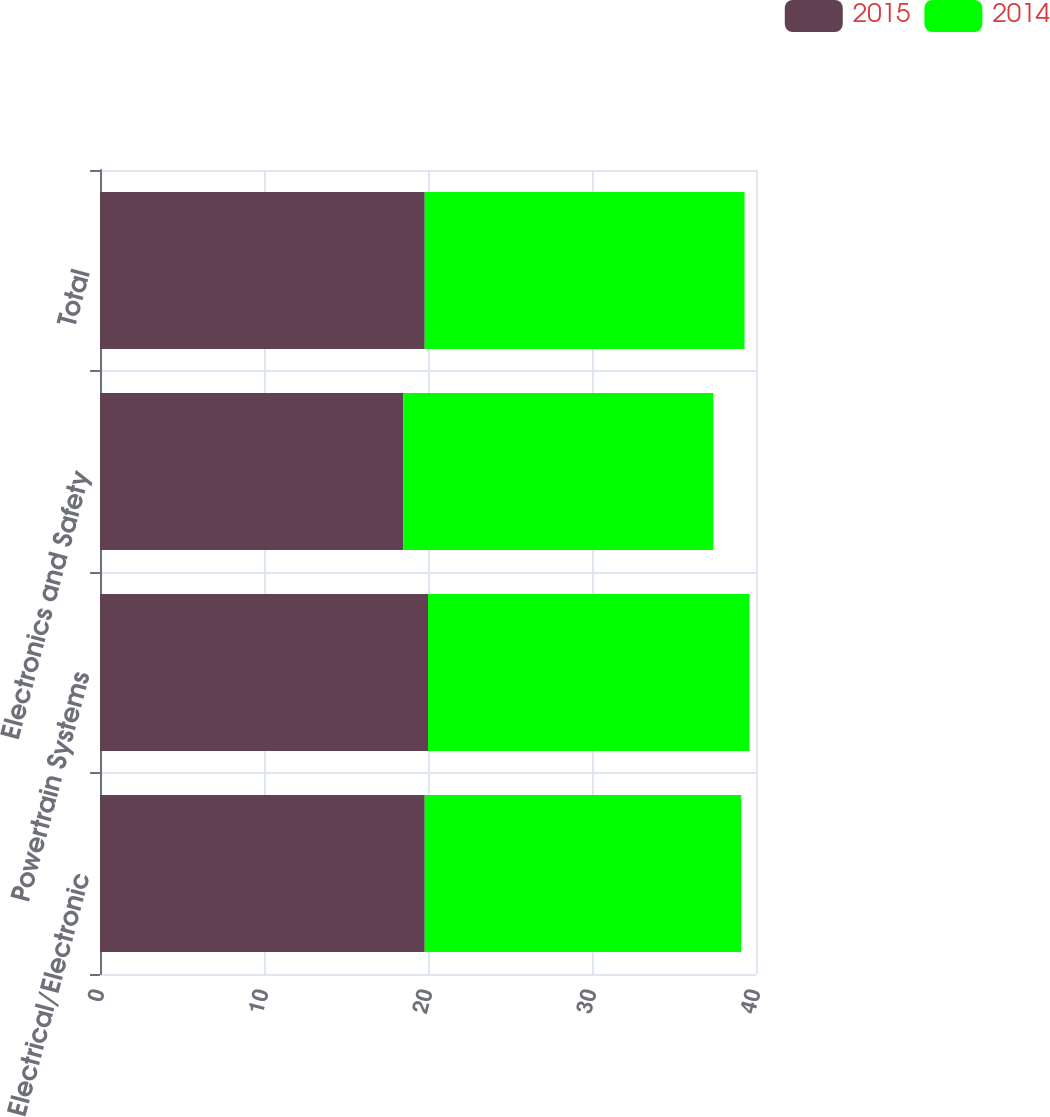Convert chart to OTSL. <chart><loc_0><loc_0><loc_500><loc_500><stacked_bar_chart><ecel><fcel>Electrical/Electronic<fcel>Powertrain Systems<fcel>Electronics and Safety<fcel>Total<nl><fcel>2015<fcel>19.8<fcel>20<fcel>18.5<fcel>19.8<nl><fcel>2014<fcel>19.3<fcel>19.6<fcel>18.9<fcel>19.5<nl></chart> 